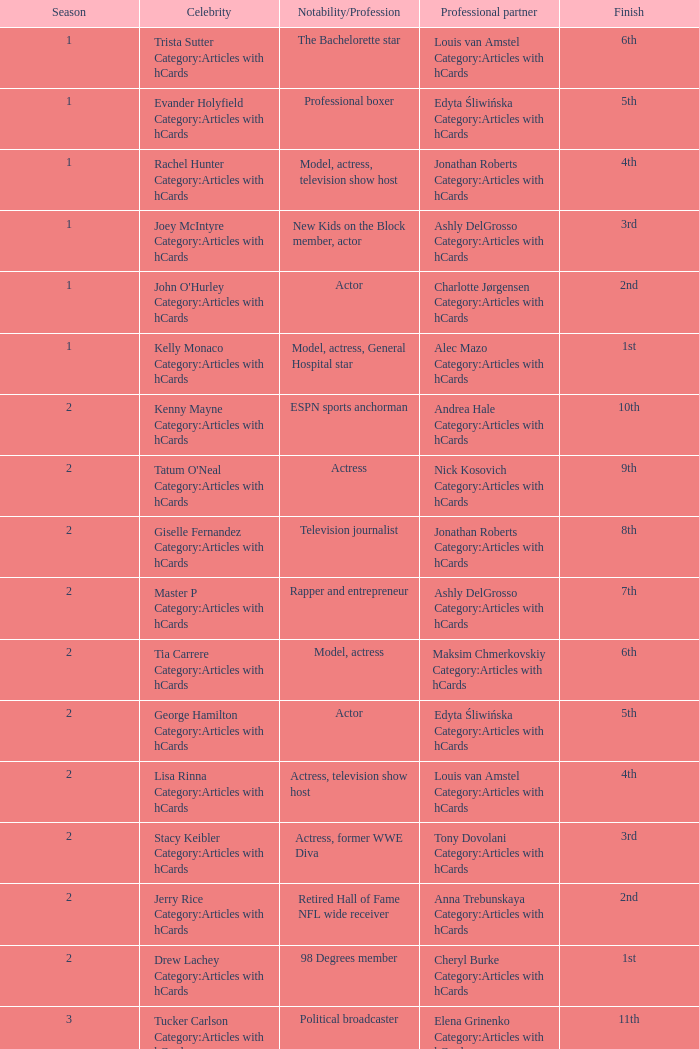What was the job of the star who was showcased in season 15 and concluded at 7th rank? Actress, comedian. 